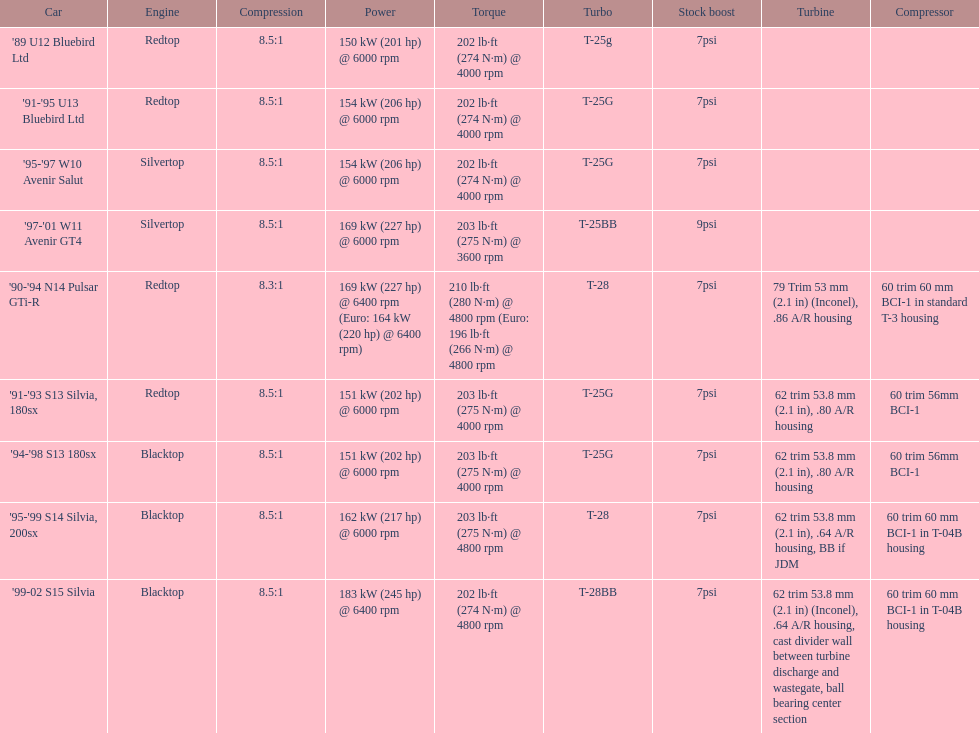How many models used the redtop engine? 4. 